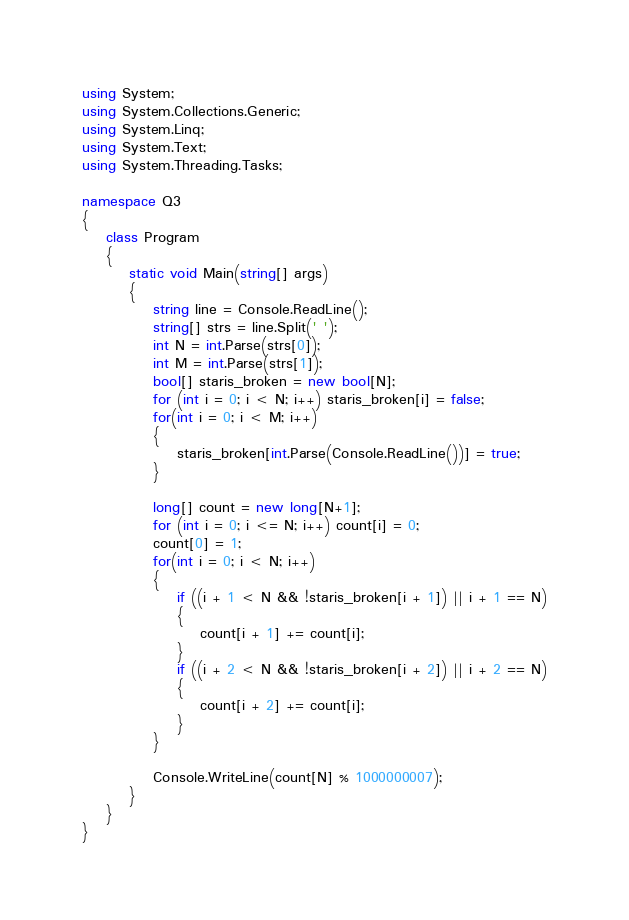Convert code to text. <code><loc_0><loc_0><loc_500><loc_500><_C#_>using System;
using System.Collections.Generic;
using System.Linq;
using System.Text;
using System.Threading.Tasks;

namespace Q3
{
    class Program
    {
        static void Main(string[] args)
        {
            string line = Console.ReadLine();
            string[] strs = line.Split(' ');
            int N = int.Parse(strs[0]);
            int M = int.Parse(strs[1]);
            bool[] staris_broken = new bool[N];
            for (int i = 0; i < N; i++) staris_broken[i] = false;
            for(int i = 0; i < M; i++)
            {
                staris_broken[int.Parse(Console.ReadLine())] = true;
            }

            long[] count = new long[N+1];
            for (int i = 0; i <= N; i++) count[i] = 0;
            count[0] = 1;
            for(int i = 0; i < N; i++)
            {
                if ((i + 1 < N && !staris_broken[i + 1]) || i + 1 == N)
                {
                    count[i + 1] += count[i];
                }
                if ((i + 2 < N && !staris_broken[i + 2]) || i + 2 == N)
                {
                    count[i + 2] += count[i];
                }
            }

            Console.WriteLine(count[N] % 1000000007);
        }
    }
}
</code> 